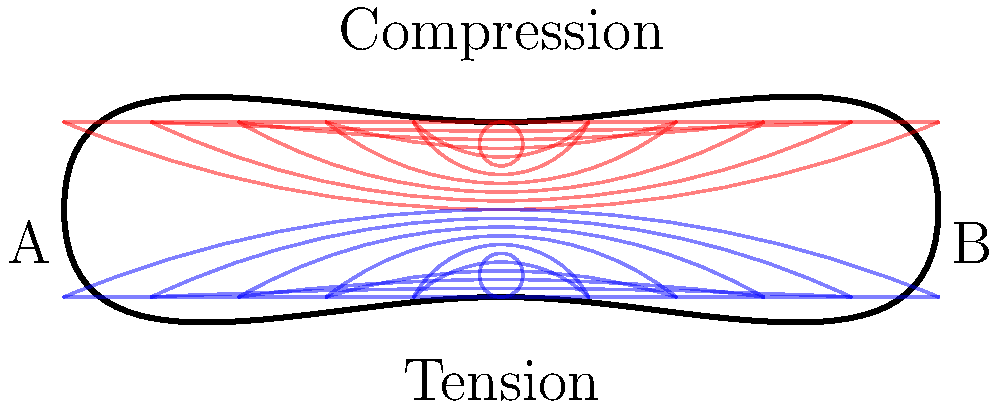In the finite element analysis of a long bone subjected to bending, as shown in the diagram, what is the primary difference in stress distribution between the upper and lower surfaces of the bone, and how might this impact the bone's susceptibility to fracture in wildlife affected by climate change-induced malnutrition? To answer this question, let's analyze the stress distribution in the bone step-by-step:

1. Stress distribution: The diagram shows a simplified representation of a long bone under bending stress.

2. Upper surface (red lines):
   - The upper surface experiences compression.
   - Stress lines are closer together, indicating higher stress concentration.

3. Lower surface (blue lines):
   - The lower surface experiences tension.
   - Stress lines are also closer together, indicating high stress concentration.

4. Neutral axis:
   - The center of the bone experiences minimal stress.
   - Stress increases as we move away from the neutral axis towards the outer surfaces.

5. Impact of stress distribution:
   - Bones are generally stronger in compression than in tension.
   - The lower surface (tension side) is typically more susceptible to failure.

6. Climate change and malnutrition:
   - Climate change can lead to food scarcity and malnutrition in wildlife.
   - Malnutrition can result in decreased bone density and strength.

7. Susceptibility to fracture:
   - Weakened bones due to malnutrition would be more prone to fracture under bending loads.
   - The tension side (lower surface) would be at higher risk of initiating a fracture.

8. Epidemiological implications:
   - Increased fracture rates could lead to higher mortality or susceptibility to predation.
   - This could potentially alter population dynamics and disease transmission patterns in wildlife.
Answer: The upper surface experiences compression while the lower surface experiences tension, making the lower surface more susceptible to fracture initiation, especially in malnourished animals with weakened bones due to climate change effects. 